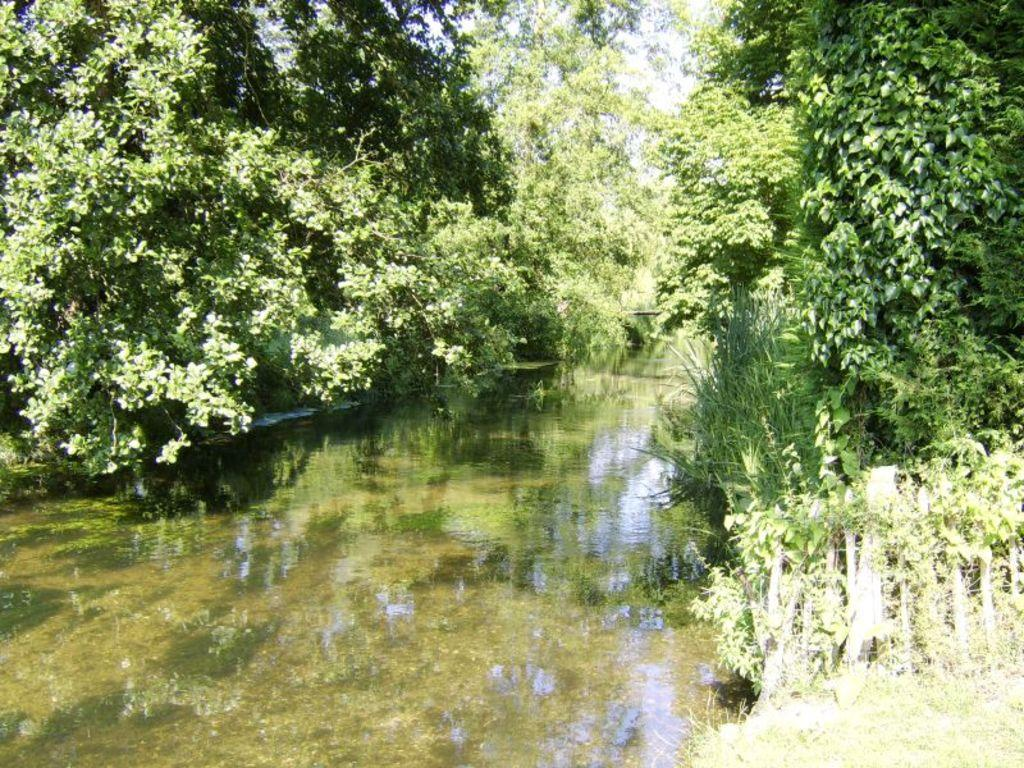What is visible in the image? There is water visible in the image. What can be seen in the background of the image? There are trees in the background of the image. What type of environment might this image depict? The image might depict a natural environment, such as a lake or river, given the presence of water and trees. How many visitors can be seen in the image? There are no visitors present in the image; it only features water and trees. What type of nest can be seen in the image? There is no nest present in the image; it only features water and trees. 